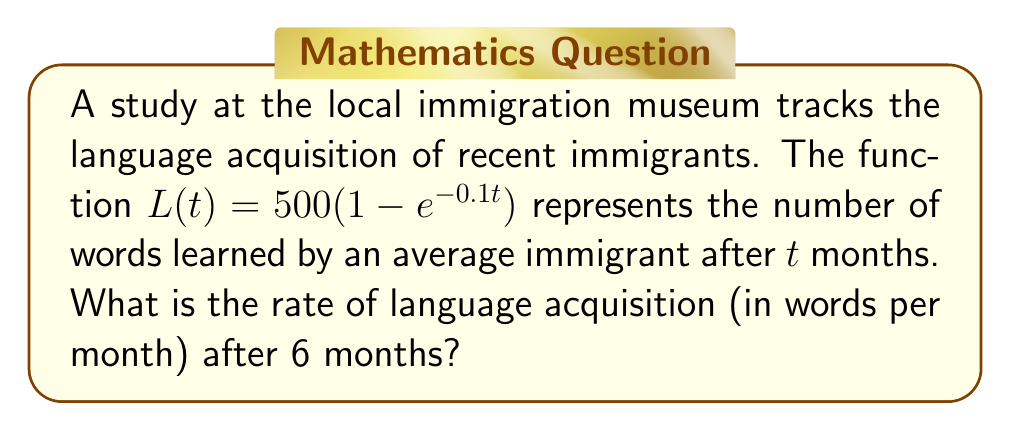Show me your answer to this math problem. To find the rate of language acquisition at 6 months, we need to find the derivative of $L(t)$ and evaluate it at $t=6$. Here's how we do it:

1) First, let's find the derivative of $L(t)$:
   
   $L(t) = 500(1 - e^{-0.1t})$
   $L'(t) = 500 \cdot \frac{d}{dt}(1 - e^{-0.1t})$
   $L'(t) = 500 \cdot (0 - (-0.1)e^{-0.1t})$
   $L'(t) = 50e^{-0.1t}$

2) Now, we evaluate $L'(t)$ at $t=6$:
   
   $L'(6) = 50e^{-0.1(6)}$
   $L'(6) = 50e^{-0.6}$

3) Using a calculator or approximating:
   
   $L'(6) \approx 50 \cdot 0.5488 \approx 27.44$

Therefore, after 6 months, the rate of language acquisition is approximately 27.44 words per month.
Answer: $27.44$ words/month 